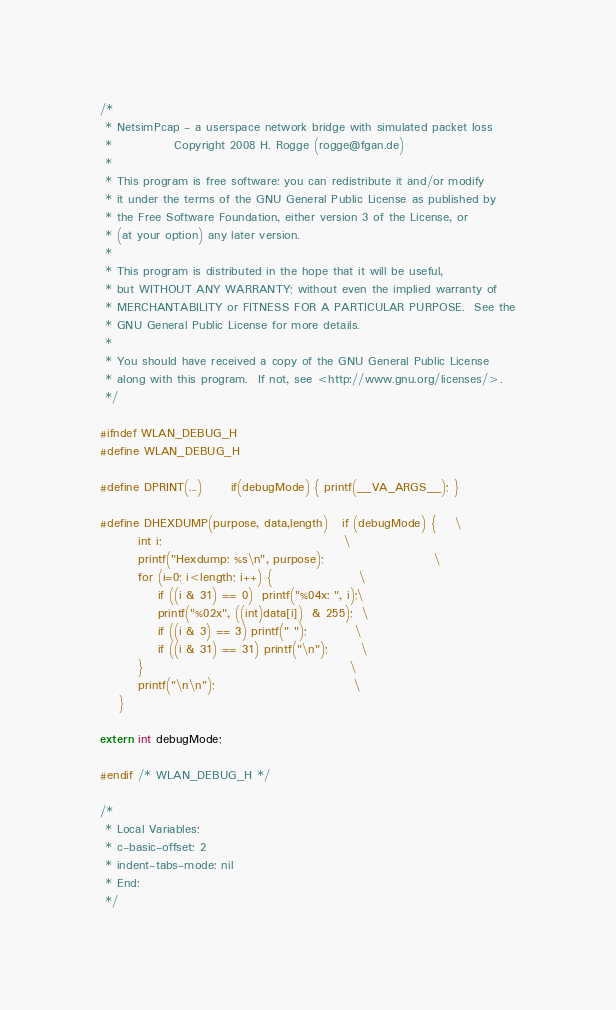Convert code to text. <code><loc_0><loc_0><loc_500><loc_500><_C_>
/*
 * NetsimPcap - a userspace network bridge with simulated packet loss
 *             Copyright 2008 H. Rogge (rogge@fgan.de)
 *
 * This program is free software: you can redistribute it and/or modify
 * it under the terms of the GNU General Public License as published by
 * the Free Software Foundation, either version 3 of the License, or
 * (at your option) any later version.
 *
 * This program is distributed in the hope that it will be useful,
 * but WITHOUT ANY WARRANTY; without even the implied warranty of
 * MERCHANTABILITY or FITNESS FOR A PARTICULAR PURPOSE.  See the
 * GNU General Public License for more details.
 *
 * You should have received a copy of the GNU General Public License
 * along with this program.  If not, see <http://www.gnu.org/licenses/>.
 */

#ifndef WLAN_DEBUG_H
#define WLAN_DEBUG_H

#define DPRINT(...)		if(debugMode) { printf(__VA_ARGS__); }

#define DHEXDUMP(purpose, data,length)	if (debugMode) {	\
		int i;										\
		printf("Hexdump: %s\n", purpose);						\
		for (i=0; i<length; i++) {					\
			if ((i & 31) == 0)	printf("%04x: ", i);\
			printf("%02x", ((int)data[i])  & 255);	\
			if ((i & 3) == 3) printf(" ");			\
			if ((i & 31) == 31) printf("\n");		\
		}											\
		printf("\n\n");								\
	}

extern int debugMode;

#endif /* WLAN_DEBUG_H */

/*
 * Local Variables:
 * c-basic-offset: 2
 * indent-tabs-mode: nil
 * End:
 */
</code> 